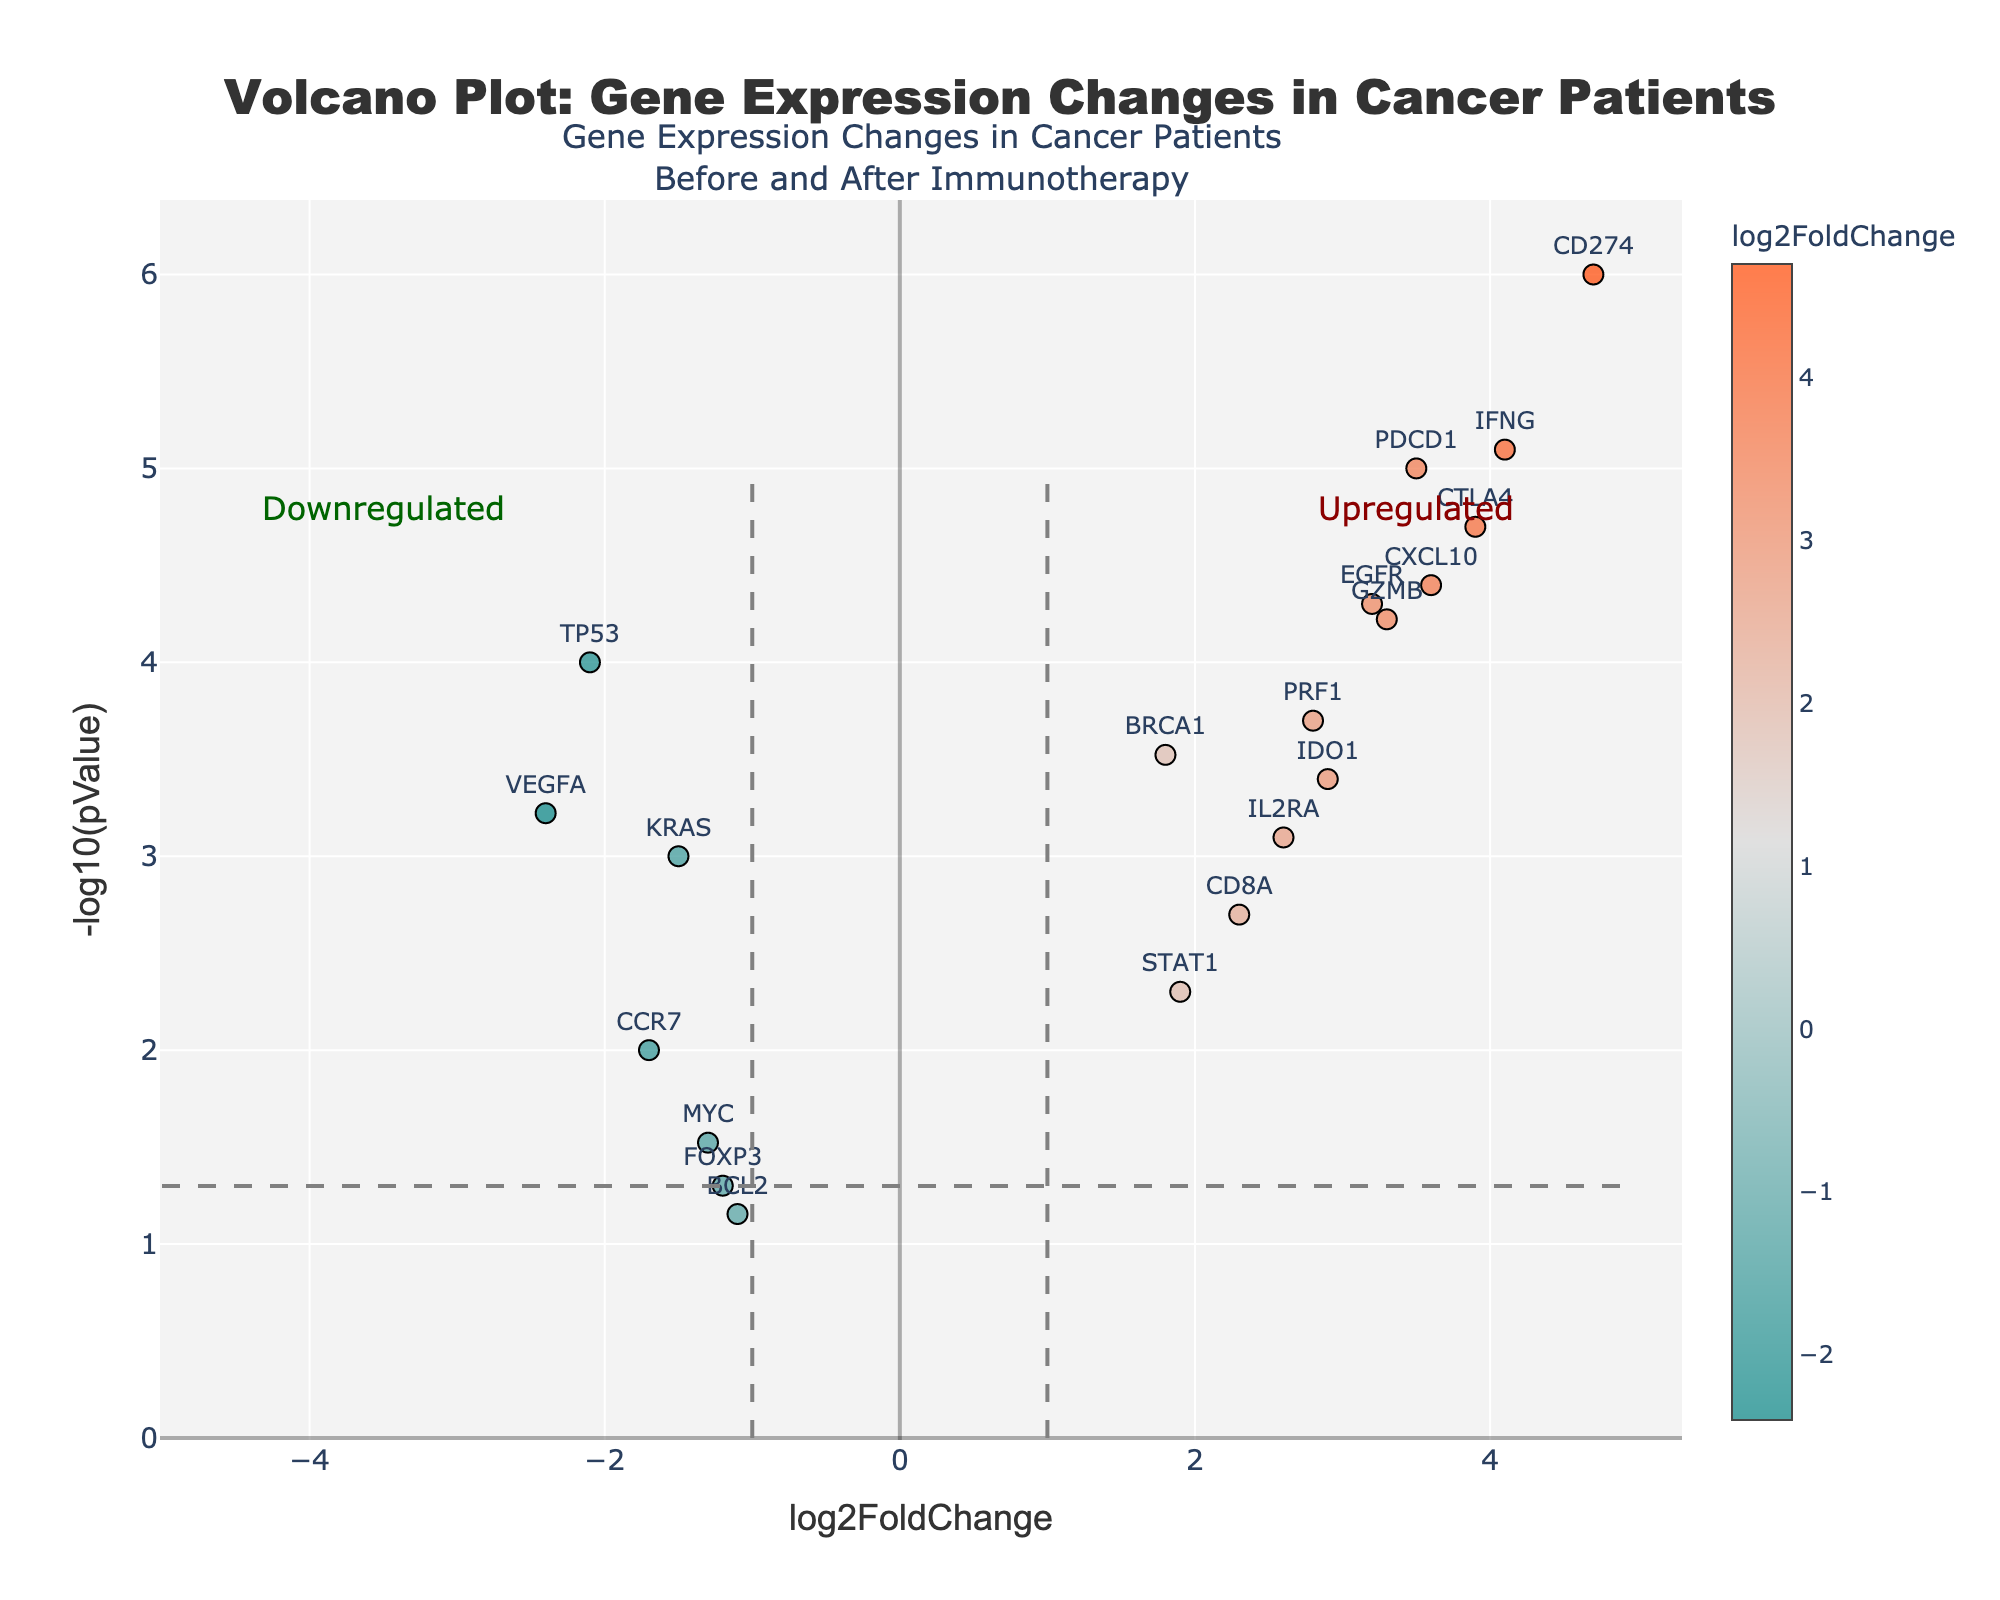what is the title of the plot? The plot's title is displayed at the top and reads "Volcano Plot: Gene Expression Changes in Cancer Patients". We can see this clearly as it is formatted in a prominent position with a distinct font size and style.
Answer: Volcano Plot: Gene Expression Changes in Cancer Patients How many genes are plotted in the figure? Each point on the plot represents a gene, and counting all the points will give us the total number of genes. In this case, we can see there are 20 points on the plot.
Answer: 20 What is the x-axis labeled as? The x-axis label is displayed along the horizontal axis and it reads "log2FoldChange".
Answer: log2FoldChange Which gene has the highest -log10(pValue)? To determine the highest -log10(pValue), we look for the point with the highest position on the y-axis. The gene at this position is CD274.
Answer: CD274 Which genes are upregulated after immunotherapy? Genes with positive log2FoldChange values are upregulated, indicated by points to the right of the x-axis. The upregulated genes are BRCA1, EGFR, CD274, CTLA4, IL2RA, PDCD1, IDO1, IFNG, GZMB, PRF1, CXCL10, CD8A, and STAT1.
Answer: BRCA1, EGFR, CD274, CTLA4, IL2RA, PDCD1, IDO1, IFNG, GZMB, PRF1, CXCL10, CD8A, STAT1 Which gene has the lowest log2FoldChange? The lowest log2FoldChange corresponds to the farthest point to the left on the x-axis. TP53 is this gene with a log2FoldChange of -2.1.
Answer: TP53 What is the log2FoldChange of the gene MYC? MYC is labeled on the plot, and its corresponding point is located at log2FoldChange value of -1.3.
Answer: -1.3 What are the threshold values on the x-axis for upregulated and downregulated genes shown in the dashed lines? The plot shows vertical dashed lines at x=-1 and x=1 indicating thresholds for upregulation and downregulation. These highlight significant changes in expression levels.
Answer: -1 and 1 Which gene has the second highest -log10(pValue)? To find the gene with the second highest -log10(pValue), identify the point second highest along the y-axis. PDCD1 has the second highest -log10(pValue).
Answer: PDCD1 What is the log2FoldChange and -log10(pValue) for FOXP3? To find these values, locate the point corresponding to FOXP3. The log2FoldChange is -1.2 and -log10(pValue) is 1.3.
Answer: -1.2 and 1.3 